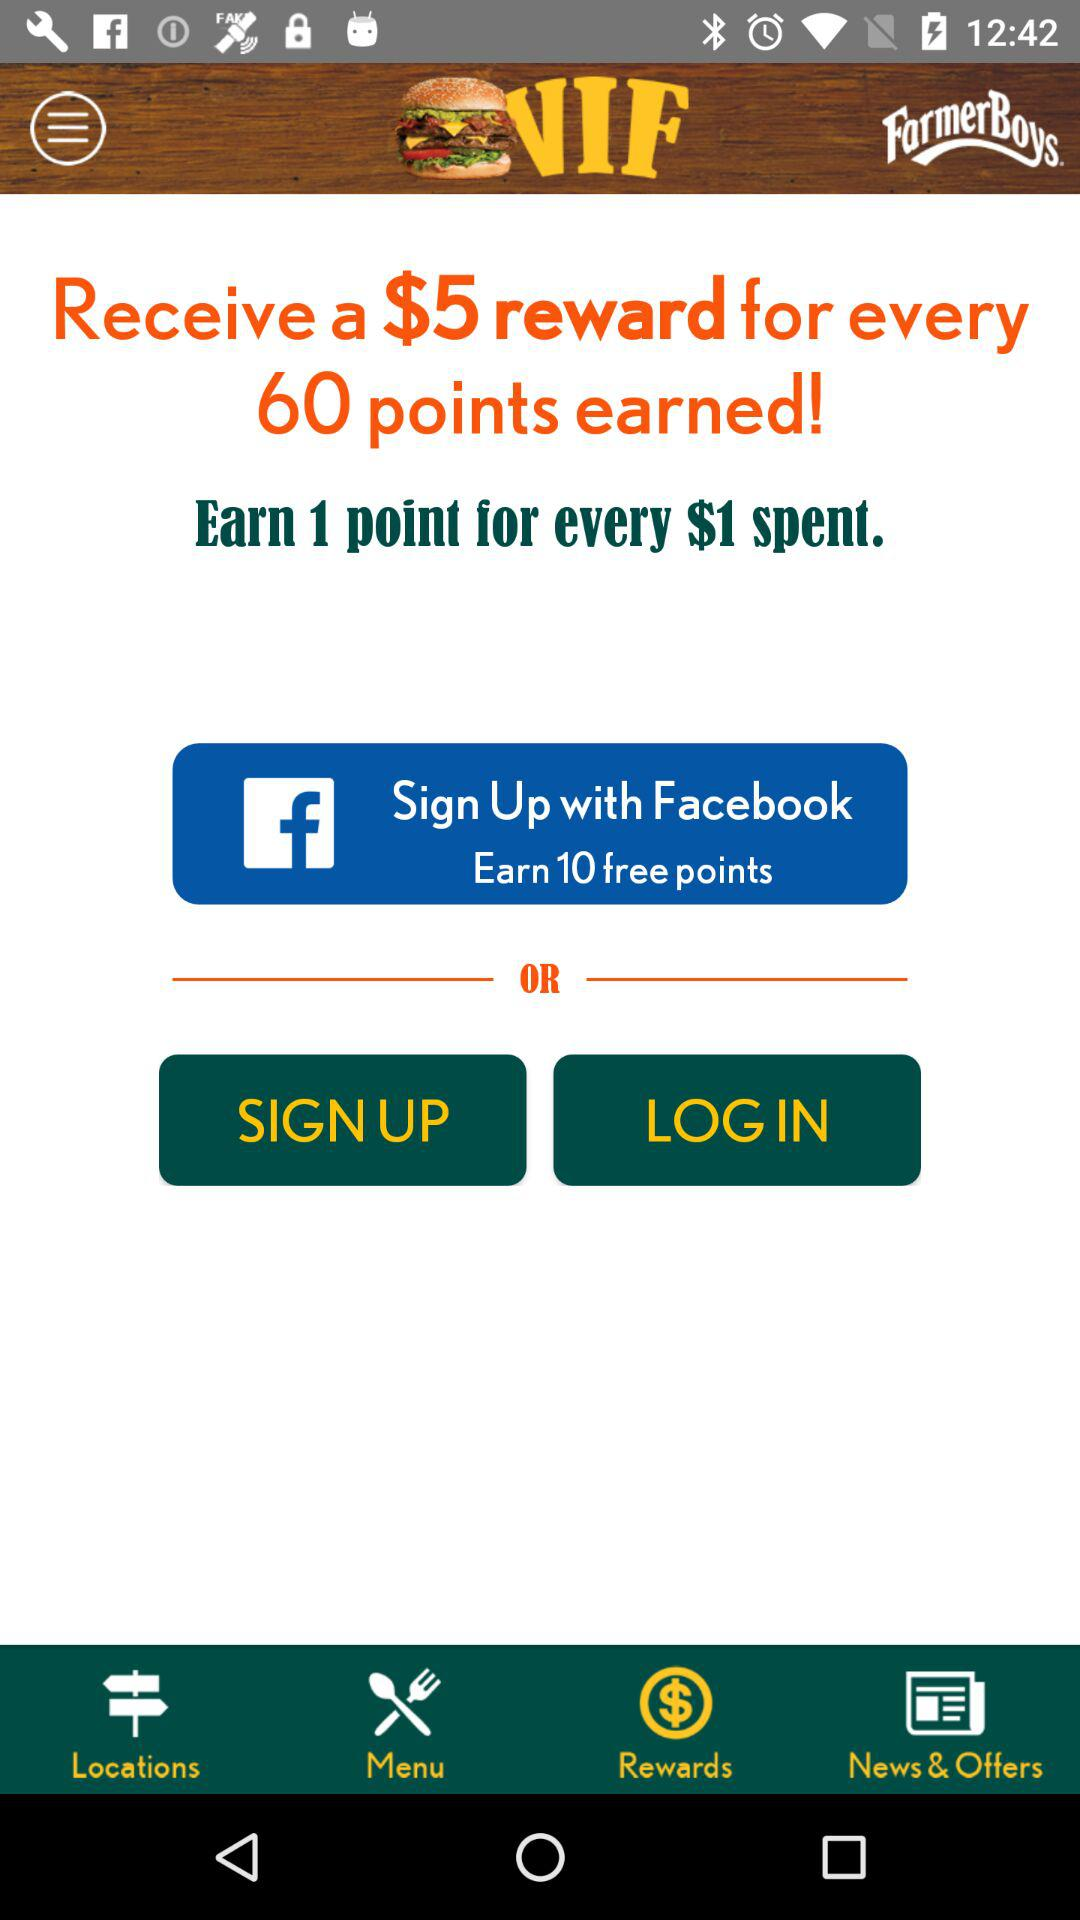What is the offer for signing up with "Facebook"? The offer is "Earn 10 free points" for signing up with "Facebook". 